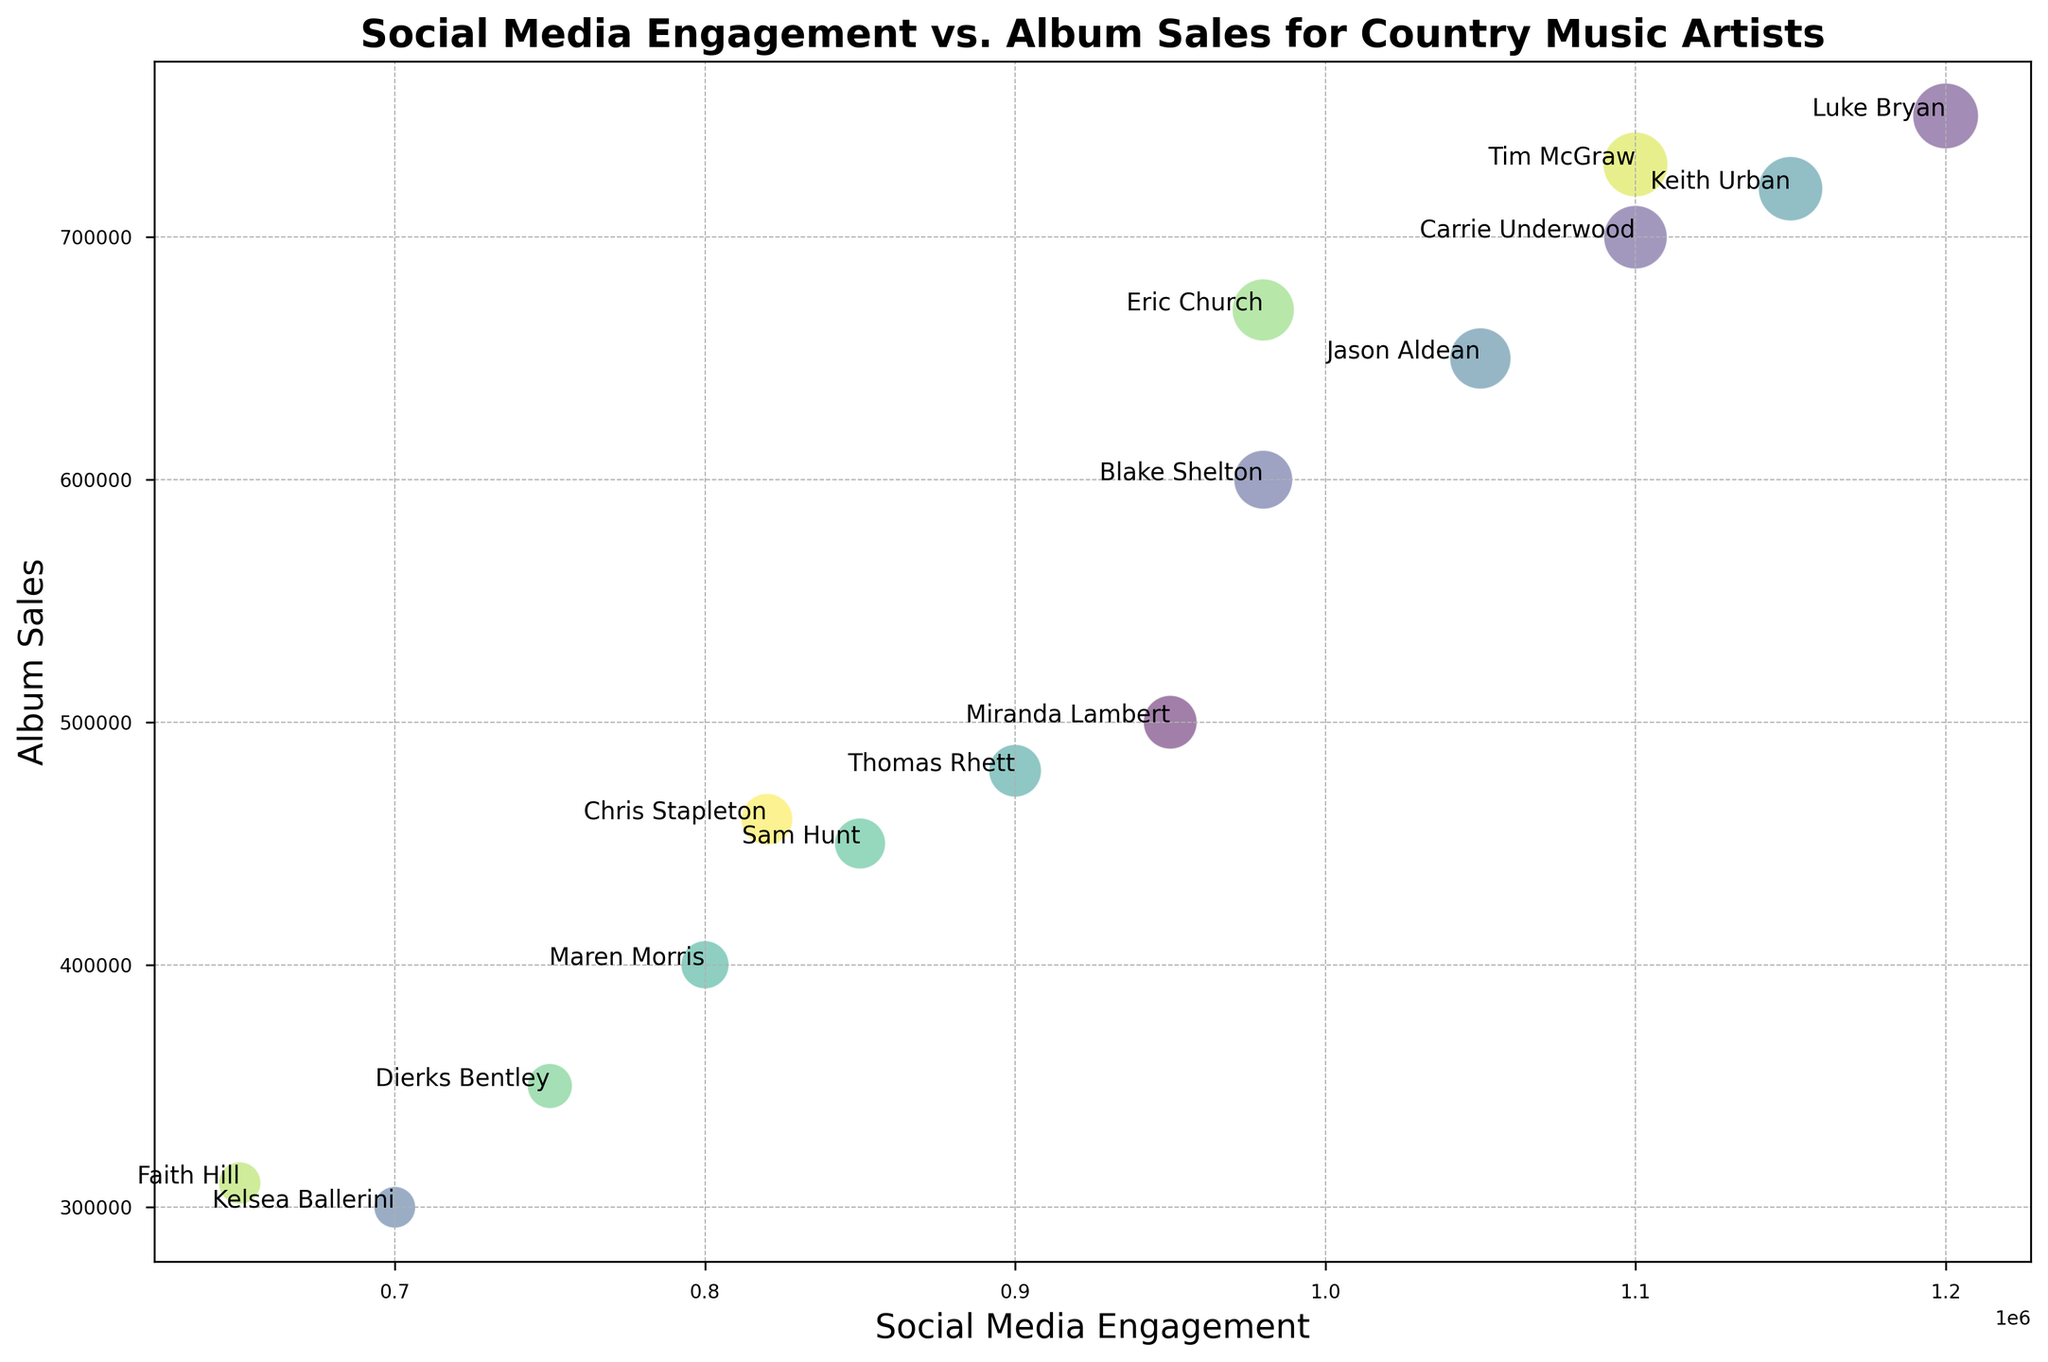Which artist has the highest social media engagement? Look at the x-axis values and identify the artist with the rightmost position on the plot.
Answer: Luke Bryan Which artist has higher album sales, Carrie Underwood or Jason Aldean? Compare the y-axis values of the two artists; the higher position indicates more album sales.
Answer: Carrie Underwood If we sum the album sales of Maren Morris and Chris Stapleton, what is the total? Add the album sales values of both artists (400,000 + 460,000).
Answer: 860,000 Which artist has lower social media engagement, Maren Morris or Dierks Bentley? Compare the x-axis values of the two artists; the leftmost position indicates lower engagement.
Answer: Dierks Bentley Which artist has the smallest bubble size among the top 5 artists with the highest album sales? Identify the top 5 artists based on y-axis values and compare their bubble sizes.
Answer: Eric Church If we take the average social media engagement of Blake Shelton and Keith Urban, what is the value? Add their social media engagement and divide by 2 ((980,000 + 1,150,000) / 2).
Answer: 1,065,000 Which artist is closest in album sales to Blake Shelton? Look for the artist with an album sales value closest to Blake Shelton's 600,000.
Answer: Jason Aldean For artists with bubble sizes greater than 60, what is the average album sales? Identify artists with bubble sizes > 60, sum their album sales, and divide by the number of such artists. (Carrie Underwood: 700,000, Luke Bryan: 750,000, Keith Urban: 720,000, Tim McGraw: 730,000, Jason Aldean: 650,000, Total = 3,550,000 / 5)
Answer: 710,000 